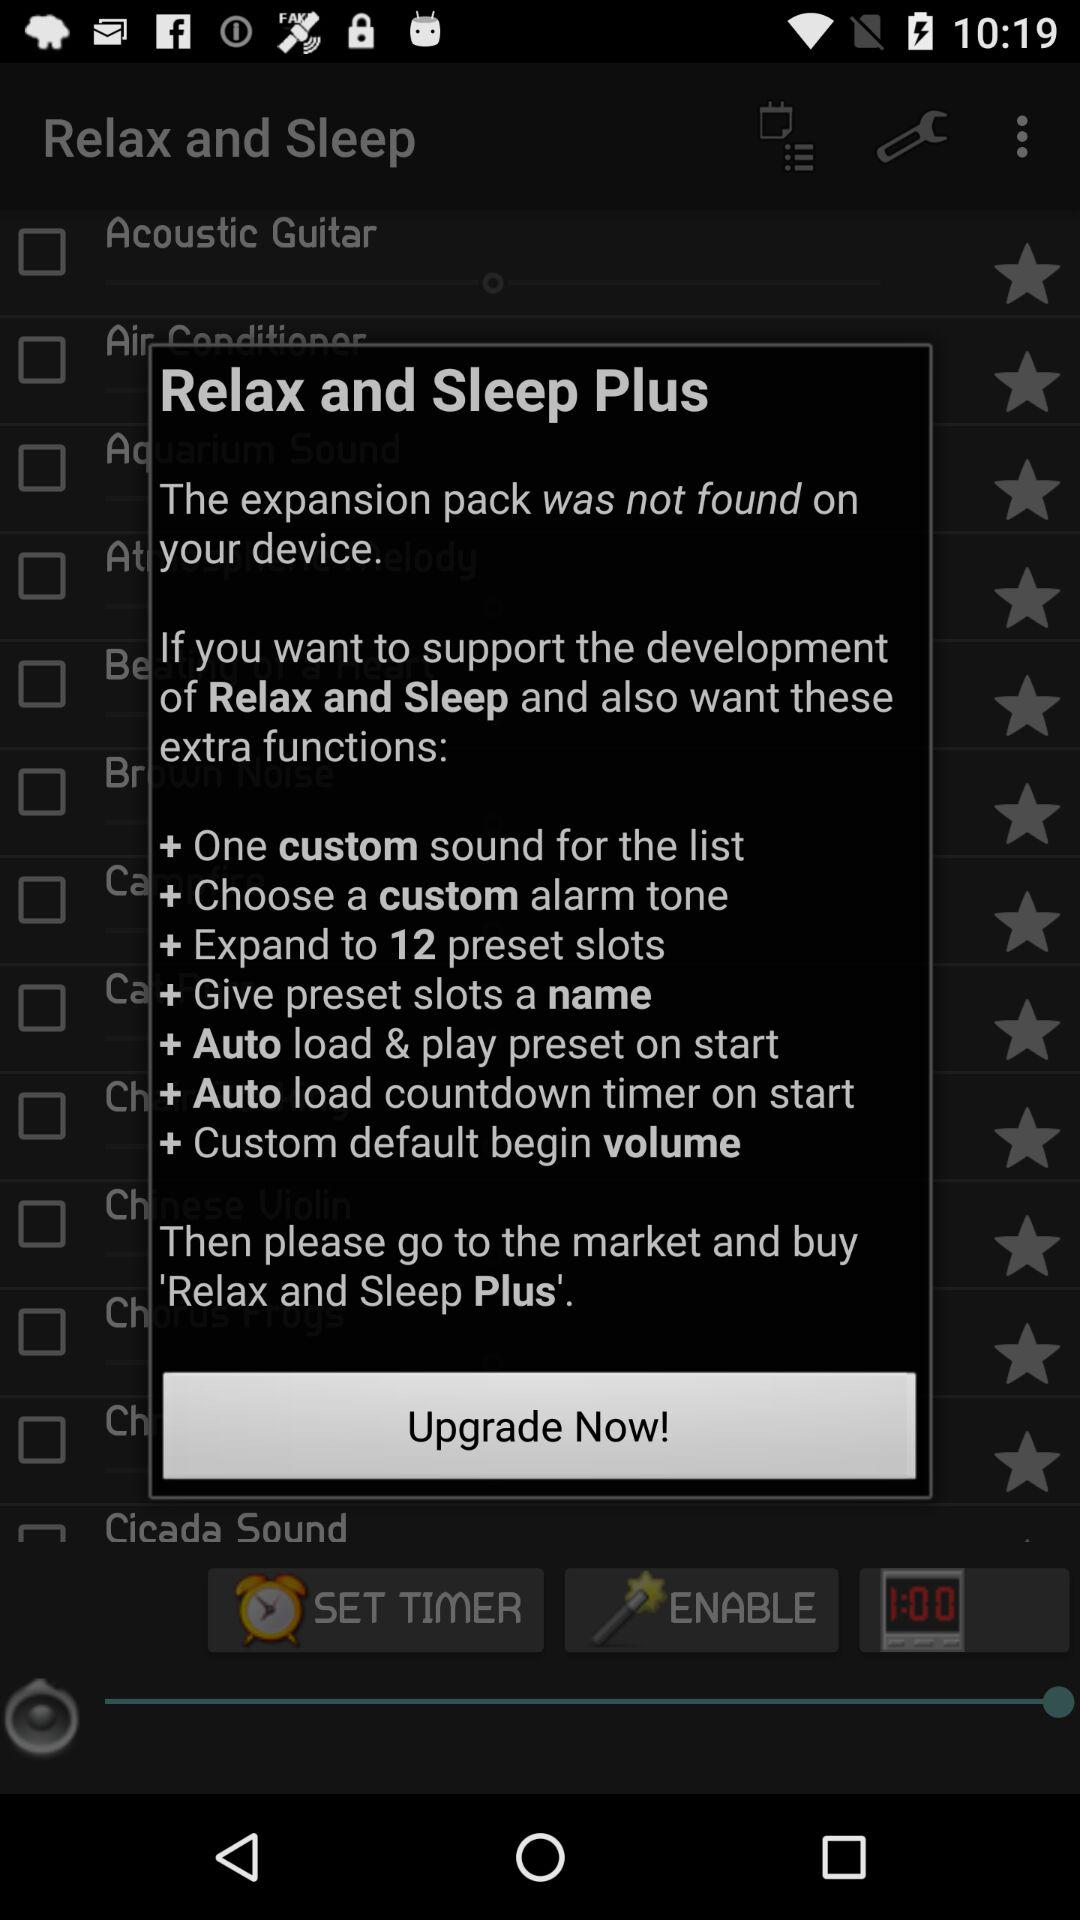How many preset slots can "Relax and Sleep Plus" be expanded to? "Relax and Sleep Plus" can be expanded to 12 preset slots. 